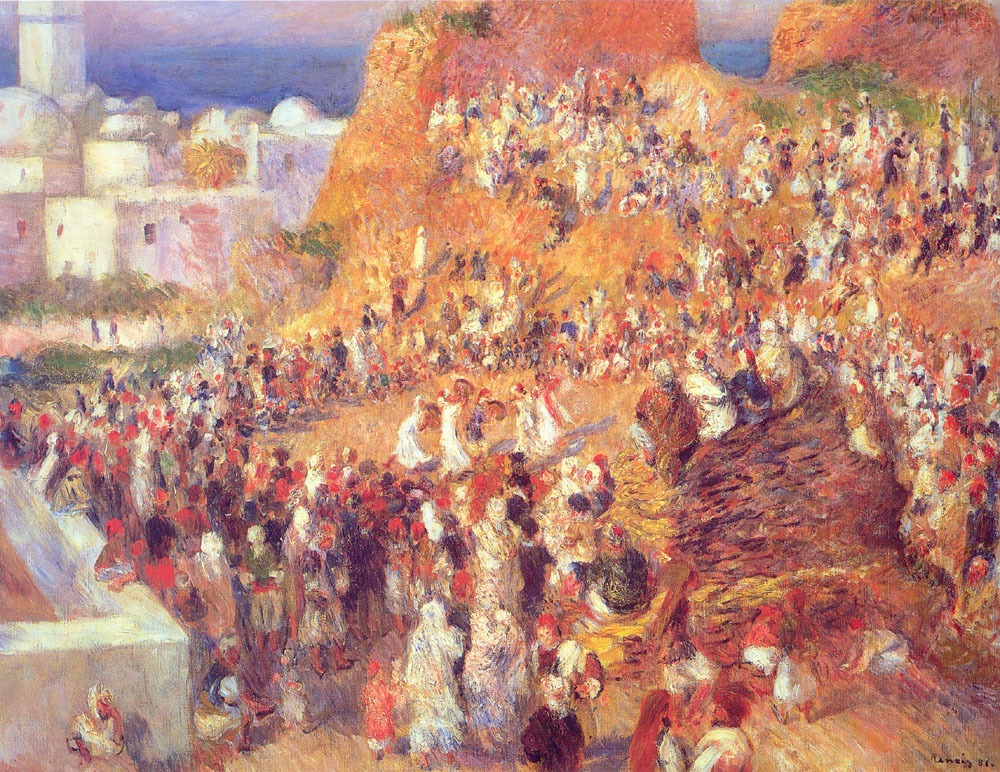Imagine this market scene comes to life. Describe the sounds and smells you would experience. If the market scene in the painting were to come to life, you would be enveloped by a symphony of sounds and a bouquet of evocative smells. The air would be filled with the lively chatter of vendors and customers negotiating and socializing, laughter from children playing, and the occasional clinking of coins exchanging hands. You would hear the clatter of pottery and metal goods, the rustling of cloth from market stalls displaying vibrant fabrics, and the rhythmic footsteps of people moving about. The smells would be just as varied and vibrant – the sweet aroma of fresh fruits, the earthy scent of vegetables, the fragrant spices, the salty breeze from the nearby sea, and perhaps a hint of freshly baked bread or sizzling street food. It would be a rich sensory tapestry that mirrors the lively visual scene laid out before you. 